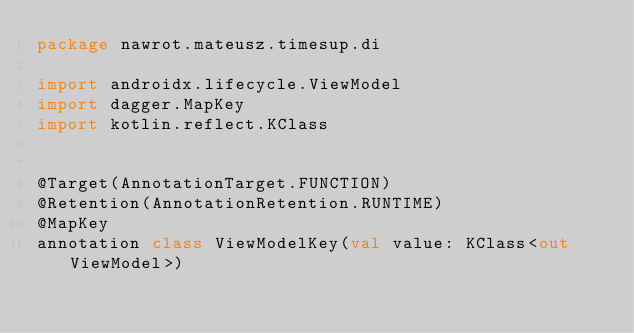<code> <loc_0><loc_0><loc_500><loc_500><_Kotlin_>package nawrot.mateusz.timesup.di

import androidx.lifecycle.ViewModel
import dagger.MapKey
import kotlin.reflect.KClass


@Target(AnnotationTarget.FUNCTION)
@Retention(AnnotationRetention.RUNTIME)
@MapKey
annotation class ViewModelKey(val value: KClass<out ViewModel>)</code> 